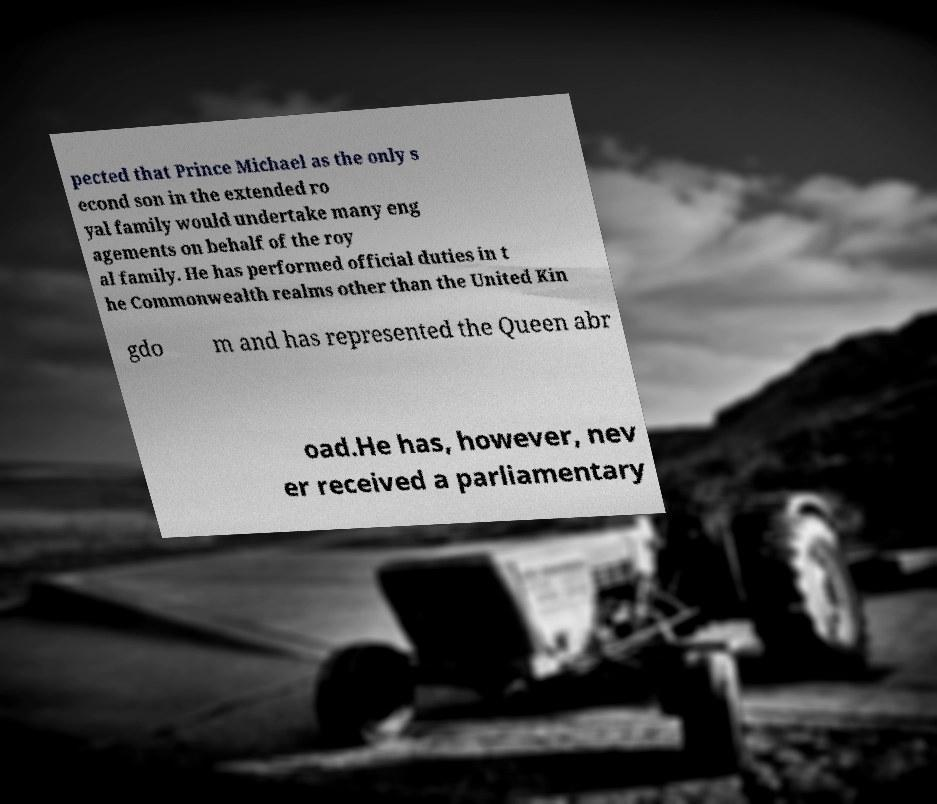I need the written content from this picture converted into text. Can you do that? pected that Prince Michael as the only s econd son in the extended ro yal family would undertake many eng agements on behalf of the roy al family. He has performed official duties in t he Commonwealth realms other than the United Kin gdo m and has represented the Queen abr oad.He has, however, nev er received a parliamentary 